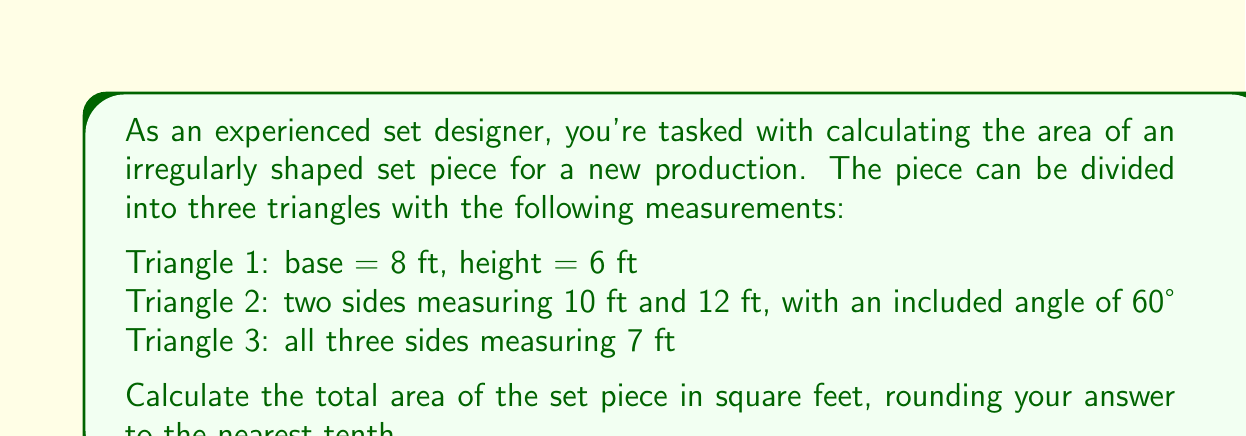Provide a solution to this math problem. Let's break this down step-by-step:

1. For Triangle 1, we can use the simple area formula for a triangle:
   $$A_1 = \frac{1}{2} \times base \times height = \frac{1}{2} \times 8 \times 6 = 24 \text{ sq ft}$$

2. For Triangle 2, we need to use the formula for the area of a triangle given two sides and the included angle:
   $$A_2 = \frac{1}{2} \times a \times b \times \sin(C)$$
   Where $a = 10$, $b = 12$, and $C = 60°$
   $$A_2 = \frac{1}{2} \times 10 \times 12 \times \sin(60°)$$
   $$A_2 = 60 \times \frac{\sqrt{3}}{2} = 30\sqrt{3} \approx 51.96 \text{ sq ft}$$

3. For Triangle 3, we have an equilateral triangle. We can use Heron's formula:
   $$A = \sqrt{s(s-a)(s-b)(s-c)}$$
   Where $s = \frac{a+b+c}{2}$ (semi-perimeter)
   
   $s = \frac{7+7+7}{2} = 10.5$
   
   $$A_3 = \sqrt{10.5(10.5-7)(10.5-7)(10.5-7)}$$
   $$A_3 = \sqrt{10.5 \times 3.5 \times 3.5 \times 3.5}$$
   $$A_3 = \sqrt{448.875} \approx 21.18 \text{ sq ft}$$

4. The total area is the sum of these three triangles:
   $$A_{total} = A_1 + A_2 + A_3$$
   $$A_{total} = 24 + 51.96 + 21.18 = 97.14 \text{ sq ft}$$

5. Rounding to the nearest tenth:
   $$A_{total} \approx 97.1 \text{ sq ft}$$
Answer: 97.1 sq ft 